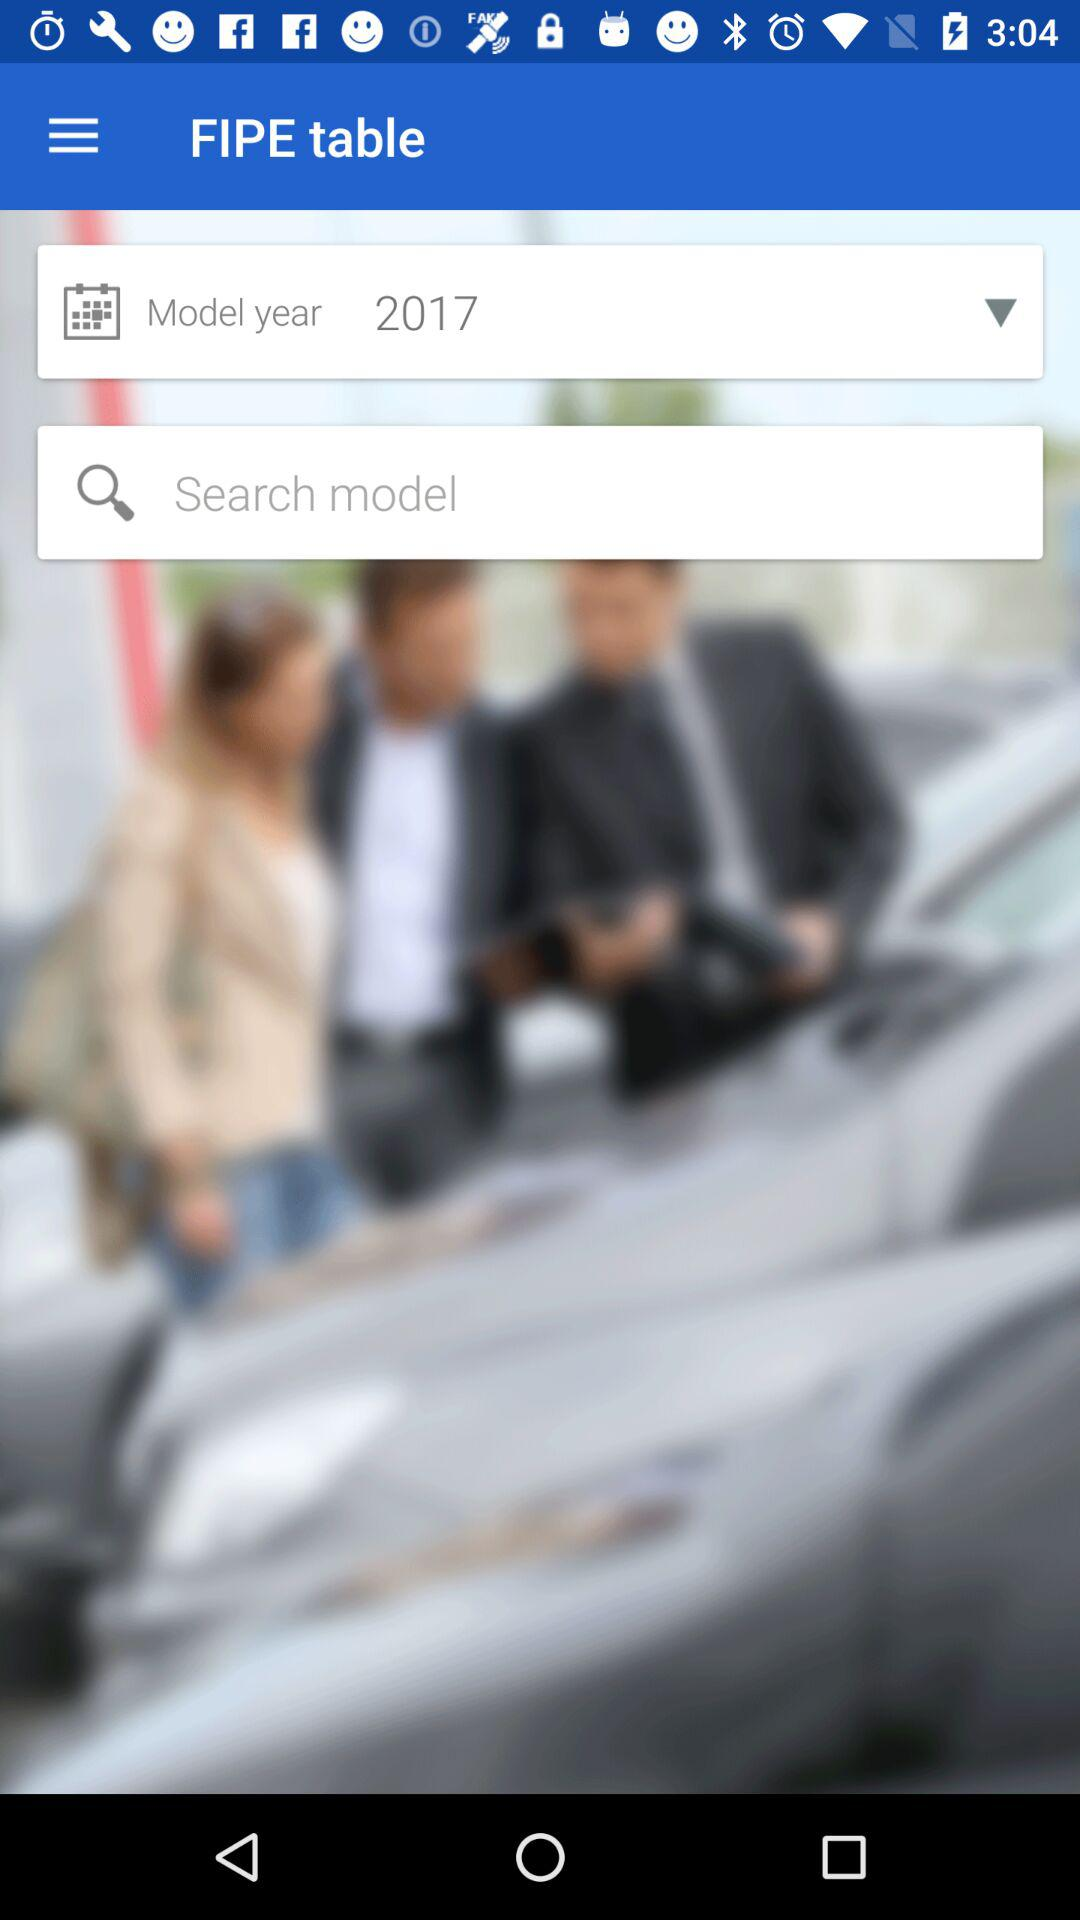What is the model year? The model year is 2017. 